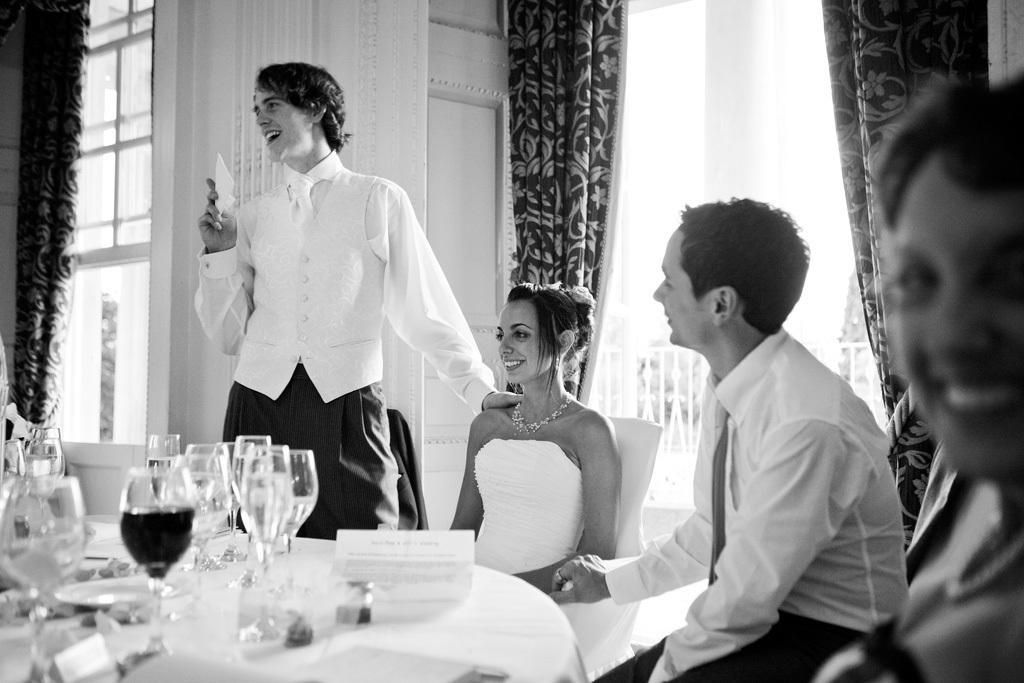Describe this image in one or two sentences. In this image we can see an inside view of a room, there are two women sitting on the chair, there is a man sitting on the chair, there is a man standing, he is holding an object, there is a table towards the bottom of the image, there are objects on the table, there are curtains towards the top of the image, there is a wall, there are windows towards the left of the image. 